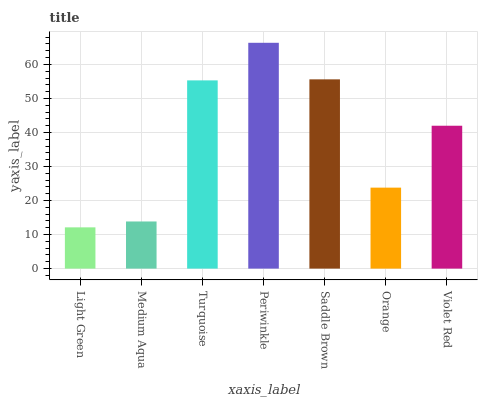Is Light Green the minimum?
Answer yes or no. Yes. Is Periwinkle the maximum?
Answer yes or no. Yes. Is Medium Aqua the minimum?
Answer yes or no. No. Is Medium Aqua the maximum?
Answer yes or no. No. Is Medium Aqua greater than Light Green?
Answer yes or no. Yes. Is Light Green less than Medium Aqua?
Answer yes or no. Yes. Is Light Green greater than Medium Aqua?
Answer yes or no. No. Is Medium Aqua less than Light Green?
Answer yes or no. No. Is Violet Red the high median?
Answer yes or no. Yes. Is Violet Red the low median?
Answer yes or no. Yes. Is Orange the high median?
Answer yes or no. No. Is Medium Aqua the low median?
Answer yes or no. No. 